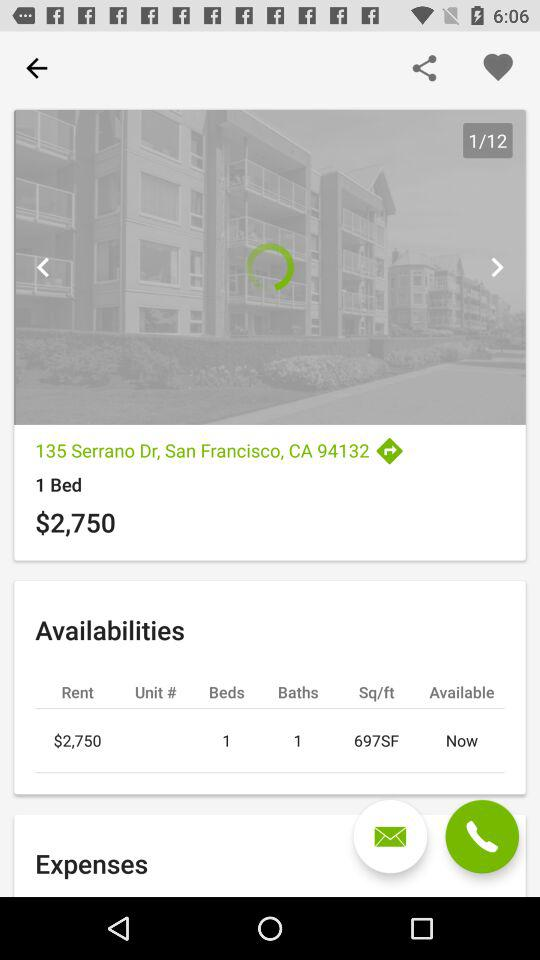What is the price? The price is $2,750. 